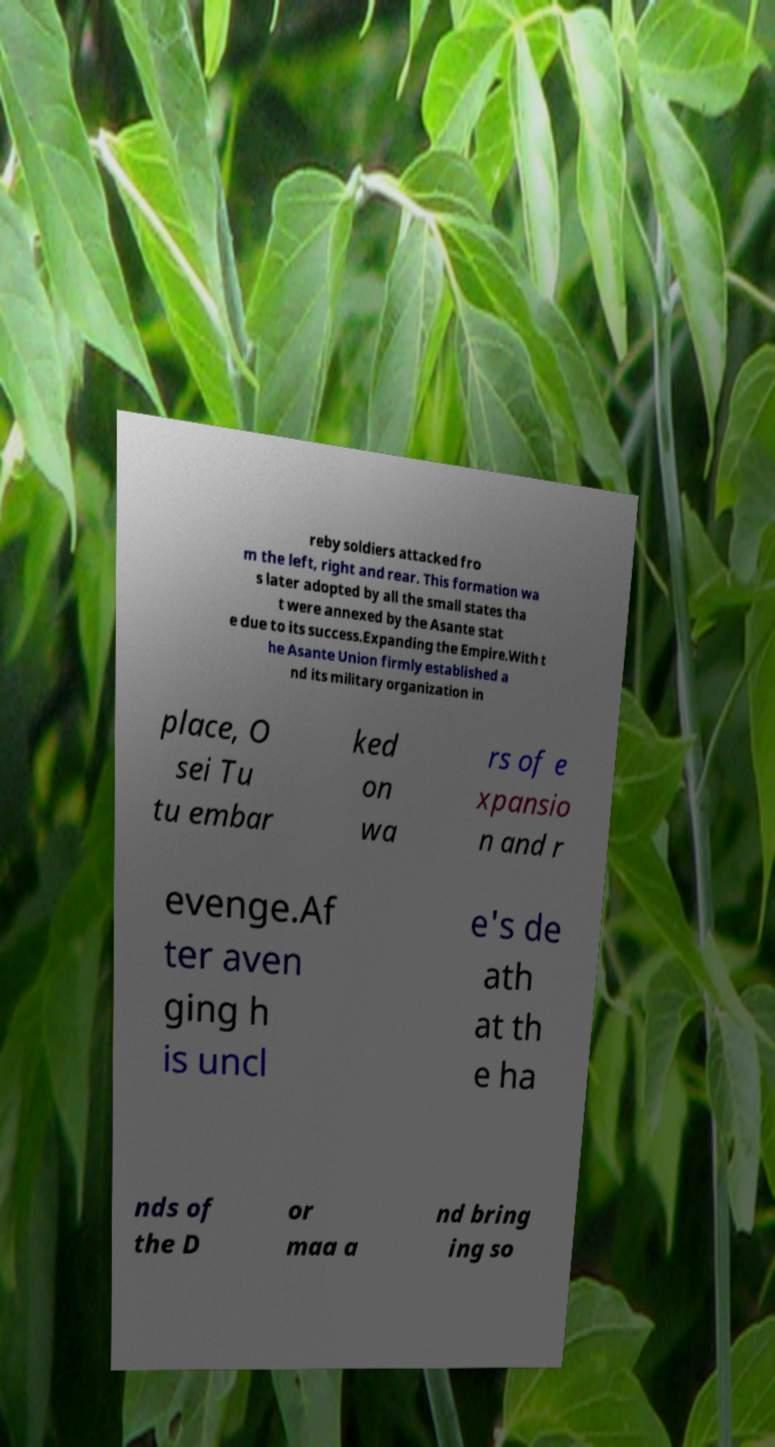I need the written content from this picture converted into text. Can you do that? reby soldiers attacked fro m the left, right and rear. This formation wa s later adopted by all the small states tha t were annexed by the Asante stat e due to its success.Expanding the Empire.With t he Asante Union firmly established a nd its military organization in place, O sei Tu tu embar ked on wa rs of e xpansio n and r evenge.Af ter aven ging h is uncl e's de ath at th e ha nds of the D or maa a nd bring ing so 